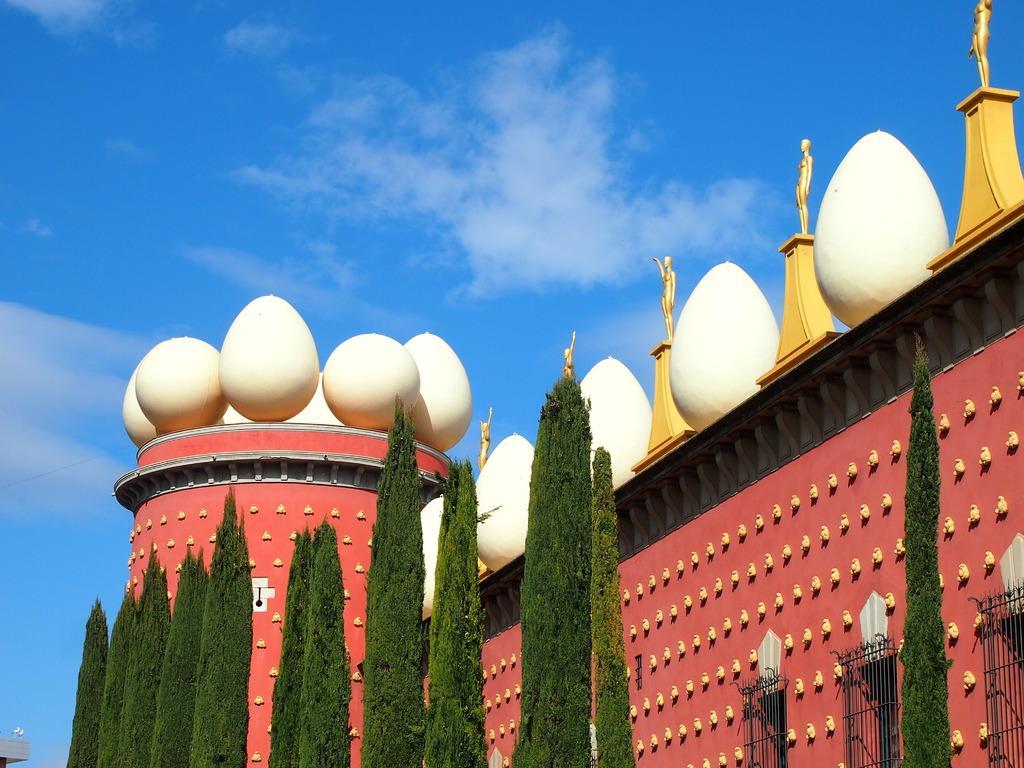In one or two sentences, can you explain what this image depicts? In the middle there are trees and this is the building, there are egg shaped structures on it. At the top it is the blue color sky. 